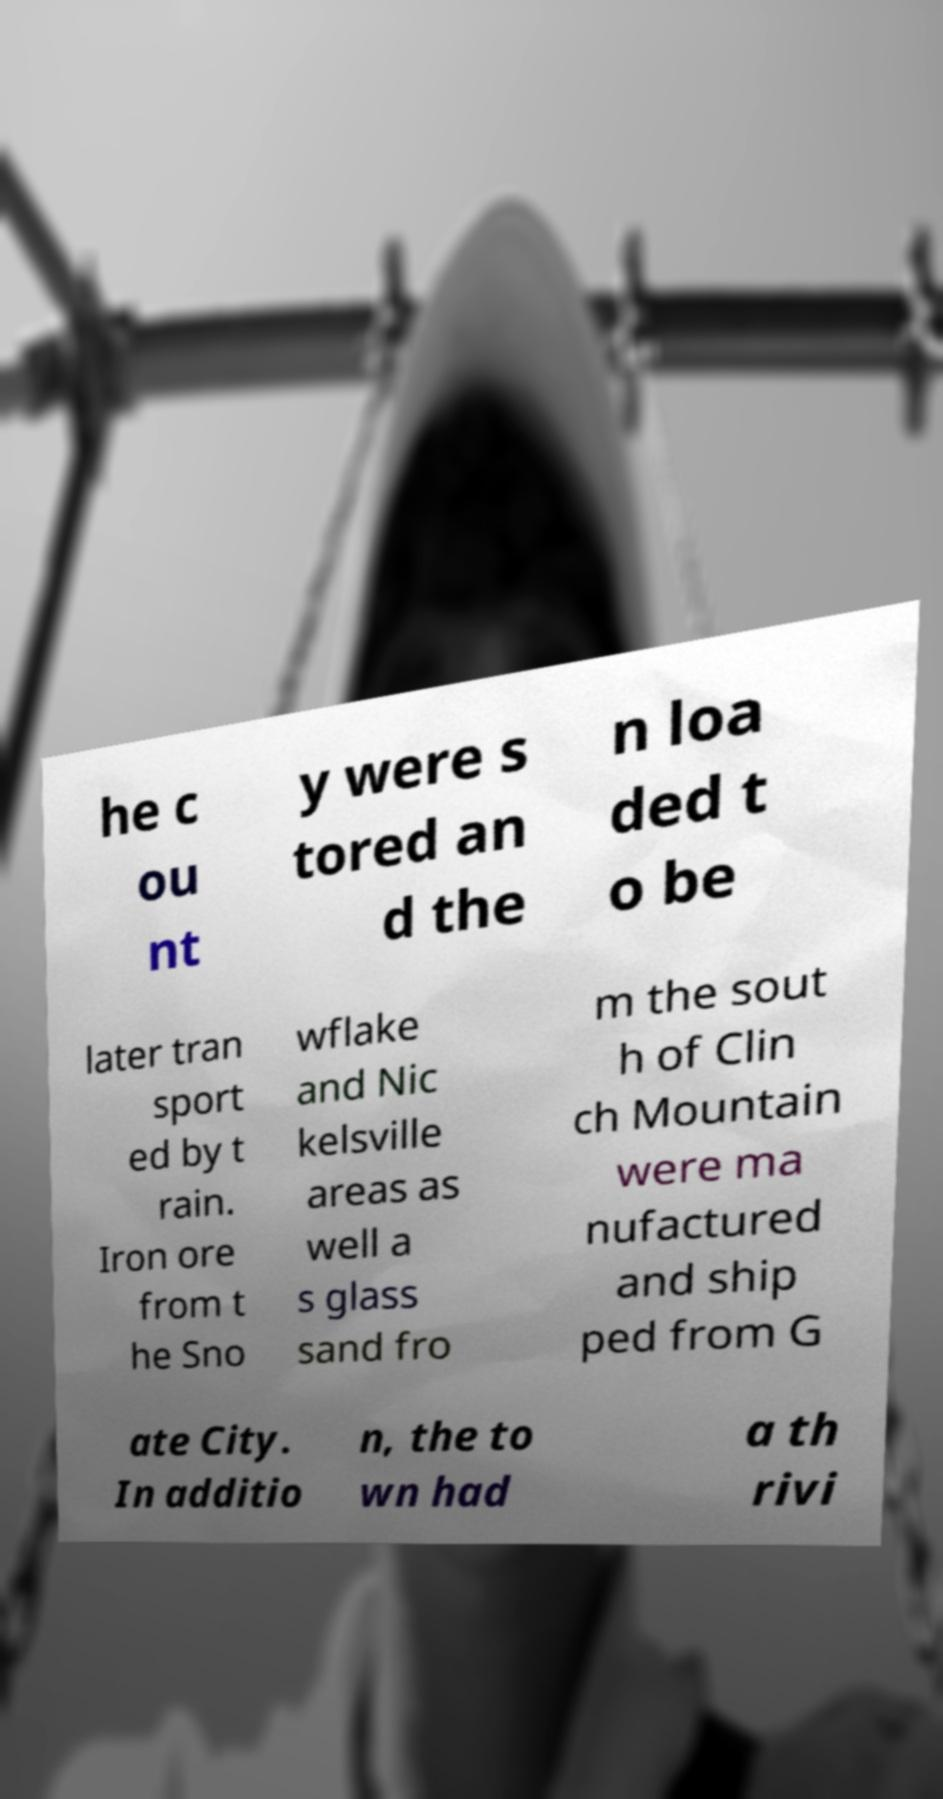Please identify and transcribe the text found in this image. he c ou nt y were s tored an d the n loa ded t o be later tran sport ed by t rain. Iron ore from t he Sno wflake and Nic kelsville areas as well a s glass sand fro m the sout h of Clin ch Mountain were ma nufactured and ship ped from G ate City. In additio n, the to wn had a th rivi 